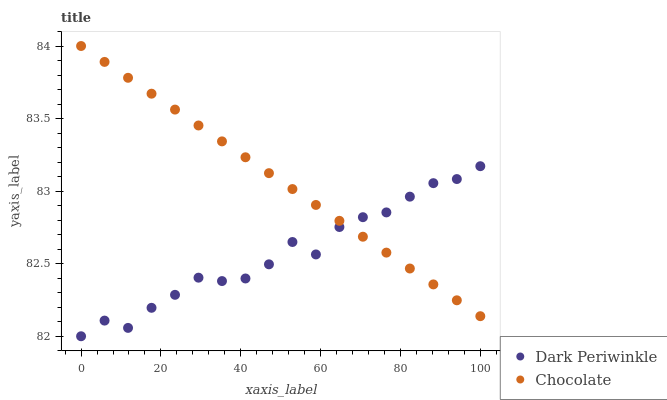Does Dark Periwinkle have the minimum area under the curve?
Answer yes or no. Yes. Does Chocolate have the maximum area under the curve?
Answer yes or no. Yes. Does Chocolate have the minimum area under the curve?
Answer yes or no. No. Is Chocolate the smoothest?
Answer yes or no. Yes. Is Dark Periwinkle the roughest?
Answer yes or no. Yes. Is Chocolate the roughest?
Answer yes or no. No. Does Dark Periwinkle have the lowest value?
Answer yes or no. Yes. Does Chocolate have the lowest value?
Answer yes or no. No. Does Chocolate have the highest value?
Answer yes or no. Yes. Does Chocolate intersect Dark Periwinkle?
Answer yes or no. Yes. Is Chocolate less than Dark Periwinkle?
Answer yes or no. No. Is Chocolate greater than Dark Periwinkle?
Answer yes or no. No. 